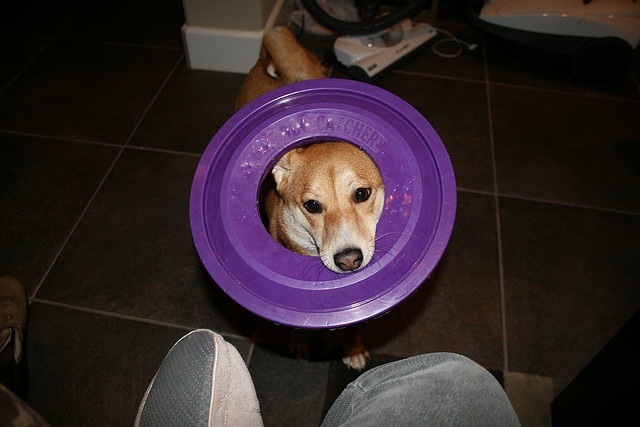Describe the objects in this image and their specific colors. I can see frisbee in black and purple tones, people in black, gray, and darkgray tones, and dog in black, maroon, gray, and tan tones in this image. 